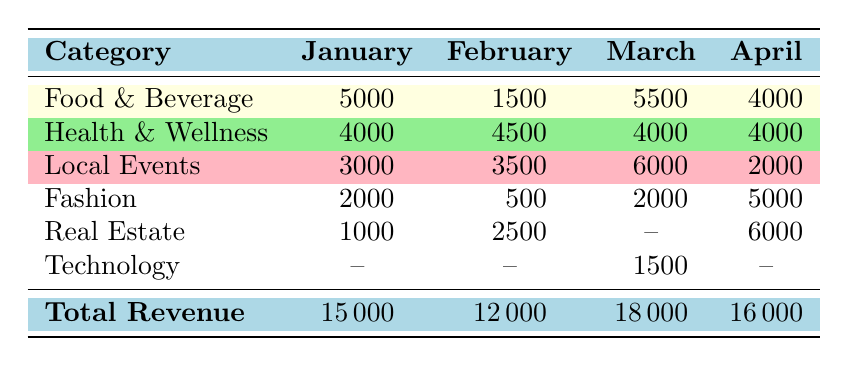what's the total revenue for March? Looking at the row labeled "Total Revenue" under the March column, we see the value listed as 18000.
Answer: 18000 how much revenue did Real Estate generate in February? In the row for Real Estate under the February column, the value is 2500.
Answer: 2500 which category had the highest revenue in January? The highest revenue can be found by comparing the revenue of each category in January: Food & Beverage (5000), Health & Wellness (4000), Local Events (3000), Fashion (2000), and Real Estate (1000). Food & Beverage has the highest at 5000.
Answer: Food & Beverage what's the total revenue from Food & Beverage over the four months? To find the total, we sum the revenue from Food & Beverage for each month: 5000 (January) + 1500 (February) + 5500 (March) + 4000 (April) = 17000.
Answer: 17000 did any category generate revenue in March that didn't generate any revenue in January? In March, the category Technology generated 1500, which is not present in January as it is marked with a dash. Therefore, yes, Technology generated revenue in March but not in January.
Answer: Yes what's the difference in Local Events revenue between February and April? The revenue for Local Events in February is 3500, and in April it is 2000. The difference is calculated as 3500 - 2000 = 1500.
Answer: 1500 which month had the lowest total revenue? The total revenues are: January (15000), February (12000), March (18000), and April (16000). The lowest total revenue is February at 12000.
Answer: February how does the revenue from Health & Wellness in January compare to its revenue in other months? The revenue for Health & Wellness in January is 4000. In February, it is 4500 (higher), in March it remains the same at 4000 (no change), and in April it is also 4000 (no change). So, it is higher in February and equal in the other two months.
Answer: Higher in February, equal in others was the advertising revenue from Fashion consistent across all months? Reviewing the values for Fashion: January (2000), February (500), March (2000), April (5000). The revenues vary, so they are not consistent.
Answer: No 